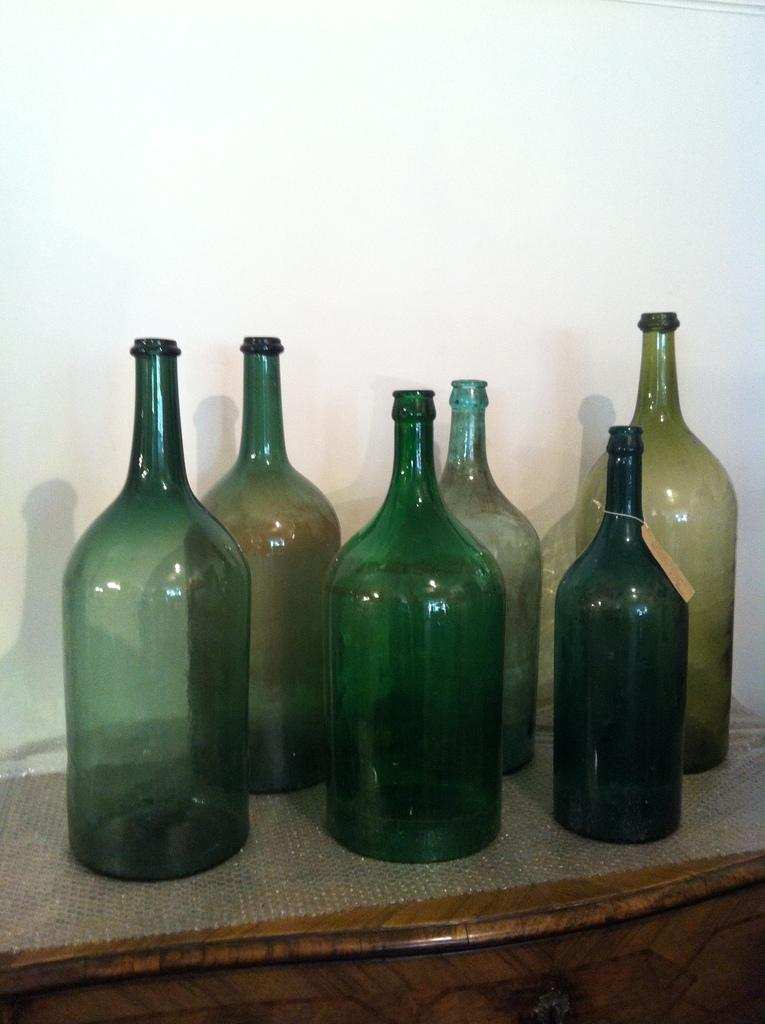How many bottles are visible in the image? There are six bottles in the image. What distinguishes the bottles from one another? The bottles have different colors. Where are the bottles placed? The bottles are on a mat. What can be seen in the background of the image? There is a wall in the background of the image. How much honey is being sold for in the image? There is no honey or indication of a sale in the image; it only features six bottles with different colors on a mat. 